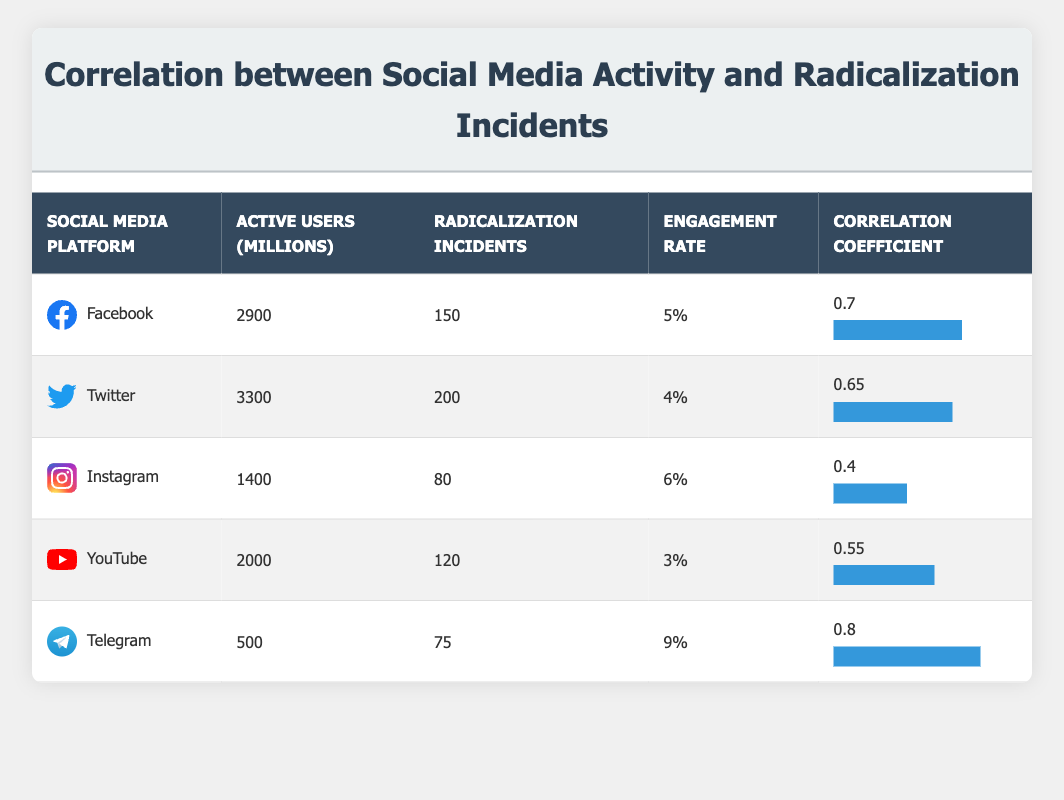What is the engagement rate for Facebook? The engagement rate for Facebook is listed in the table under the relevant column. It states that the engagement rate is 5%.
Answer: 5% Which social media platform has the highest number of active users? The table lists active users for each platform; Facebook has 2900 active users, while Twitter has 3300, which is the highest value.
Answer: Twitter What is the correlation coefficient for Telegram? The correlation coefficient for Telegram is indicated in the table, which shows it to be 0.8.
Answer: 0.8 What is the total number of radicalization incidents for all platforms combined? To find the total, sum the radicalization incidents for each platform: 150 (Facebook) + 200 (Twitter) + 80 (Instagram) + 120 (YouTube) + 75 (Telegram) = 625.
Answer: 625 Is the engagement rate for Instagram higher than that for YouTube? The engagement rate for Instagram is 6%, while that for YouTube is 3%, which indicates that Instagram's engagement rate is higher.
Answer: Yes Which platform has the lowest correlation coefficient, and what is that value? The lowest correlation coefficient is found by comparing all values in the column. Instagram has the lowest coefficient at 0.4.
Answer: Instagram, 0.4 What is the average number of radicalization incidents across all platforms? To find the average, sum the radicalization incidents (150 + 200 + 80 + 120 + 75 = 625) and divide by the number of platforms (5). This results in an average of 125.
Answer: 125 Does Twitter have a higher engagement rate than Facebook? Twitter's engagement rate is 4%, while Facebook's engagement rate is 5%, indicating that Twitter does not have a higher rate.
Answer: No What is the difference in correlation coefficients between Facebook and Telegram? The correlation coefficient for Facebook is 0.7 and Telegram is 0.8; the difference is calculated as 0.8 - 0.7 = 0.1.
Answer: 0.1 